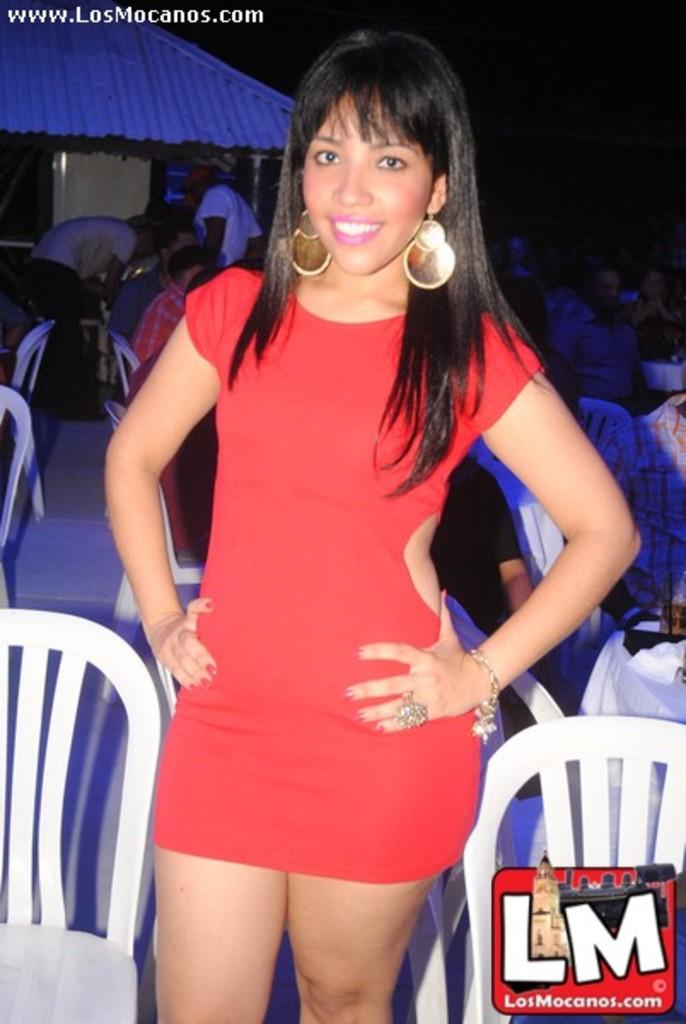What's their website link?
Provide a succinct answer. Losmocanos.com. 